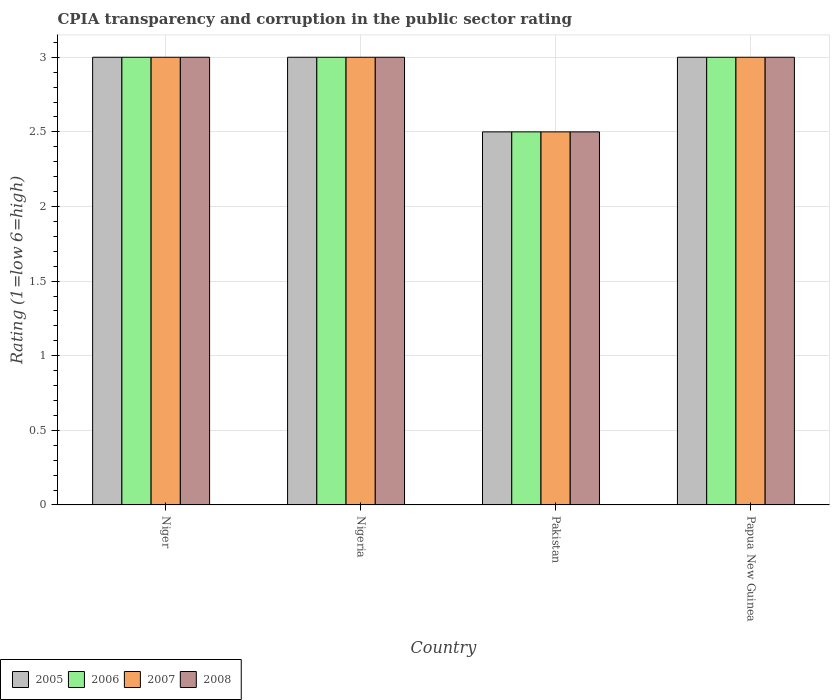How many groups of bars are there?
Offer a terse response. 4. Are the number of bars per tick equal to the number of legend labels?
Offer a terse response. Yes. Are the number of bars on each tick of the X-axis equal?
Keep it short and to the point. Yes. How many bars are there on the 2nd tick from the right?
Keep it short and to the point. 4. What is the label of the 3rd group of bars from the left?
Offer a terse response. Pakistan. Across all countries, what is the maximum CPIA rating in 2006?
Ensure brevity in your answer.  3. Across all countries, what is the minimum CPIA rating in 2005?
Provide a succinct answer. 2.5. In which country was the CPIA rating in 2008 maximum?
Keep it short and to the point. Niger. In which country was the CPIA rating in 2005 minimum?
Ensure brevity in your answer.  Pakistan. What is the difference between the CPIA rating in 2007 in Niger and the CPIA rating in 2006 in Papua New Guinea?
Your response must be concise. 0. What is the average CPIA rating in 2006 per country?
Make the answer very short. 2.88. In how many countries, is the CPIA rating in 2008 greater than 0.8?
Offer a very short reply. 4. Is the CPIA rating in 2005 in Nigeria less than that in Pakistan?
Ensure brevity in your answer.  No. Is the difference between the CPIA rating in 2007 in Niger and Papua New Guinea greater than the difference between the CPIA rating in 2008 in Niger and Papua New Guinea?
Offer a very short reply. No. In how many countries, is the CPIA rating in 2006 greater than the average CPIA rating in 2006 taken over all countries?
Keep it short and to the point. 3. What does the 4th bar from the left in Pakistan represents?
Your answer should be compact. 2008. What does the 4th bar from the right in Nigeria represents?
Give a very brief answer. 2005. Is it the case that in every country, the sum of the CPIA rating in 2008 and CPIA rating in 2006 is greater than the CPIA rating in 2005?
Keep it short and to the point. Yes. How many bars are there?
Keep it short and to the point. 16. Are all the bars in the graph horizontal?
Ensure brevity in your answer.  No. What is the difference between two consecutive major ticks on the Y-axis?
Ensure brevity in your answer.  0.5. Does the graph contain any zero values?
Your answer should be compact. No. How many legend labels are there?
Make the answer very short. 4. What is the title of the graph?
Your response must be concise. CPIA transparency and corruption in the public sector rating. What is the Rating (1=low 6=high) in 2006 in Niger?
Offer a terse response. 3. What is the Rating (1=low 6=high) in 2007 in Niger?
Your answer should be compact. 3. What is the Rating (1=low 6=high) of 2008 in Niger?
Ensure brevity in your answer.  3. What is the Rating (1=low 6=high) in 2006 in Nigeria?
Your answer should be very brief. 3. What is the Rating (1=low 6=high) of 2008 in Nigeria?
Ensure brevity in your answer.  3. What is the Rating (1=low 6=high) in 2005 in Pakistan?
Provide a short and direct response. 2.5. What is the Rating (1=low 6=high) of 2005 in Papua New Guinea?
Offer a very short reply. 3. What is the Rating (1=low 6=high) in 2006 in Papua New Guinea?
Offer a terse response. 3. Across all countries, what is the maximum Rating (1=low 6=high) of 2006?
Provide a short and direct response. 3. Across all countries, what is the minimum Rating (1=low 6=high) of 2008?
Provide a succinct answer. 2.5. What is the total Rating (1=low 6=high) of 2005 in the graph?
Offer a very short reply. 11.5. What is the total Rating (1=low 6=high) of 2006 in the graph?
Your answer should be very brief. 11.5. What is the total Rating (1=low 6=high) of 2008 in the graph?
Your response must be concise. 11.5. What is the difference between the Rating (1=low 6=high) of 2006 in Niger and that in Nigeria?
Provide a short and direct response. 0. What is the difference between the Rating (1=low 6=high) of 2005 in Niger and that in Pakistan?
Make the answer very short. 0.5. What is the difference between the Rating (1=low 6=high) of 2007 in Niger and that in Pakistan?
Provide a succinct answer. 0.5. What is the difference between the Rating (1=low 6=high) of 2006 in Niger and that in Papua New Guinea?
Your answer should be very brief. 0. What is the difference between the Rating (1=low 6=high) in 2007 in Niger and that in Papua New Guinea?
Offer a terse response. 0. What is the difference between the Rating (1=low 6=high) of 2008 in Niger and that in Papua New Guinea?
Offer a very short reply. 0. What is the difference between the Rating (1=low 6=high) in 2006 in Nigeria and that in Pakistan?
Your answer should be very brief. 0.5. What is the difference between the Rating (1=low 6=high) in 2007 in Nigeria and that in Pakistan?
Provide a short and direct response. 0.5. What is the difference between the Rating (1=low 6=high) of 2008 in Nigeria and that in Pakistan?
Give a very brief answer. 0.5. What is the difference between the Rating (1=low 6=high) of 2005 in Nigeria and that in Papua New Guinea?
Provide a short and direct response. 0. What is the difference between the Rating (1=low 6=high) of 2007 in Nigeria and that in Papua New Guinea?
Ensure brevity in your answer.  0. What is the difference between the Rating (1=low 6=high) in 2008 in Nigeria and that in Papua New Guinea?
Your answer should be very brief. 0. What is the difference between the Rating (1=low 6=high) of 2005 in Pakistan and that in Papua New Guinea?
Give a very brief answer. -0.5. What is the difference between the Rating (1=low 6=high) in 2005 in Niger and the Rating (1=low 6=high) in 2008 in Nigeria?
Keep it short and to the point. 0. What is the difference between the Rating (1=low 6=high) of 2006 in Niger and the Rating (1=low 6=high) of 2007 in Nigeria?
Provide a succinct answer. 0. What is the difference between the Rating (1=low 6=high) in 2006 in Niger and the Rating (1=low 6=high) in 2008 in Nigeria?
Provide a succinct answer. 0. What is the difference between the Rating (1=low 6=high) in 2007 in Niger and the Rating (1=low 6=high) in 2008 in Nigeria?
Give a very brief answer. 0. What is the difference between the Rating (1=low 6=high) of 2005 in Niger and the Rating (1=low 6=high) of 2006 in Pakistan?
Your answer should be very brief. 0.5. What is the difference between the Rating (1=low 6=high) of 2005 in Niger and the Rating (1=low 6=high) of 2007 in Pakistan?
Provide a short and direct response. 0.5. What is the difference between the Rating (1=low 6=high) in 2005 in Niger and the Rating (1=low 6=high) in 2008 in Pakistan?
Offer a terse response. 0.5. What is the difference between the Rating (1=low 6=high) in 2006 in Niger and the Rating (1=low 6=high) in 2007 in Pakistan?
Your answer should be very brief. 0.5. What is the difference between the Rating (1=low 6=high) of 2006 in Niger and the Rating (1=low 6=high) of 2008 in Pakistan?
Provide a succinct answer. 0.5. What is the difference between the Rating (1=low 6=high) of 2007 in Niger and the Rating (1=low 6=high) of 2008 in Pakistan?
Your response must be concise. 0.5. What is the difference between the Rating (1=low 6=high) in 2005 in Niger and the Rating (1=low 6=high) in 2007 in Papua New Guinea?
Ensure brevity in your answer.  0. What is the difference between the Rating (1=low 6=high) of 2006 in Niger and the Rating (1=low 6=high) of 2008 in Papua New Guinea?
Your response must be concise. 0. What is the difference between the Rating (1=low 6=high) of 2005 in Nigeria and the Rating (1=low 6=high) of 2006 in Pakistan?
Offer a very short reply. 0.5. What is the difference between the Rating (1=low 6=high) in 2005 in Nigeria and the Rating (1=low 6=high) in 2007 in Pakistan?
Ensure brevity in your answer.  0.5. What is the difference between the Rating (1=low 6=high) in 2005 in Nigeria and the Rating (1=low 6=high) in 2008 in Pakistan?
Keep it short and to the point. 0.5. What is the difference between the Rating (1=low 6=high) in 2006 in Nigeria and the Rating (1=low 6=high) in 2007 in Pakistan?
Your answer should be very brief. 0.5. What is the difference between the Rating (1=low 6=high) in 2006 in Nigeria and the Rating (1=low 6=high) in 2008 in Pakistan?
Provide a succinct answer. 0.5. What is the difference between the Rating (1=low 6=high) of 2005 in Nigeria and the Rating (1=low 6=high) of 2007 in Papua New Guinea?
Your answer should be very brief. 0. What is the difference between the Rating (1=low 6=high) in 2005 in Nigeria and the Rating (1=low 6=high) in 2008 in Papua New Guinea?
Your answer should be very brief. 0. What is the difference between the Rating (1=low 6=high) of 2006 in Nigeria and the Rating (1=low 6=high) of 2007 in Papua New Guinea?
Offer a very short reply. 0. What is the difference between the Rating (1=low 6=high) in 2006 in Nigeria and the Rating (1=low 6=high) in 2008 in Papua New Guinea?
Offer a terse response. 0. What is the difference between the Rating (1=low 6=high) in 2005 in Pakistan and the Rating (1=low 6=high) in 2006 in Papua New Guinea?
Make the answer very short. -0.5. What is the difference between the Rating (1=low 6=high) of 2005 in Pakistan and the Rating (1=low 6=high) of 2008 in Papua New Guinea?
Offer a terse response. -0.5. What is the difference between the Rating (1=low 6=high) of 2006 in Pakistan and the Rating (1=low 6=high) of 2007 in Papua New Guinea?
Give a very brief answer. -0.5. What is the difference between the Rating (1=low 6=high) of 2006 in Pakistan and the Rating (1=low 6=high) of 2008 in Papua New Guinea?
Offer a very short reply. -0.5. What is the difference between the Rating (1=low 6=high) of 2007 in Pakistan and the Rating (1=low 6=high) of 2008 in Papua New Guinea?
Give a very brief answer. -0.5. What is the average Rating (1=low 6=high) of 2005 per country?
Keep it short and to the point. 2.88. What is the average Rating (1=low 6=high) of 2006 per country?
Your answer should be very brief. 2.88. What is the average Rating (1=low 6=high) in 2007 per country?
Provide a succinct answer. 2.88. What is the average Rating (1=low 6=high) in 2008 per country?
Your response must be concise. 2.88. What is the difference between the Rating (1=low 6=high) of 2005 and Rating (1=low 6=high) of 2007 in Niger?
Your answer should be very brief. 0. What is the difference between the Rating (1=low 6=high) of 2006 and Rating (1=low 6=high) of 2008 in Niger?
Offer a very short reply. 0. What is the difference between the Rating (1=low 6=high) of 2006 and Rating (1=low 6=high) of 2007 in Nigeria?
Your response must be concise. 0. What is the difference between the Rating (1=low 6=high) of 2006 and Rating (1=low 6=high) of 2008 in Nigeria?
Make the answer very short. 0. What is the difference between the Rating (1=low 6=high) of 2005 and Rating (1=low 6=high) of 2006 in Pakistan?
Offer a terse response. 0. What is the difference between the Rating (1=low 6=high) of 2006 and Rating (1=low 6=high) of 2007 in Pakistan?
Offer a terse response. 0. What is the difference between the Rating (1=low 6=high) of 2006 and Rating (1=low 6=high) of 2008 in Papua New Guinea?
Give a very brief answer. 0. What is the difference between the Rating (1=low 6=high) in 2007 and Rating (1=low 6=high) in 2008 in Papua New Guinea?
Keep it short and to the point. 0. What is the ratio of the Rating (1=low 6=high) of 2008 in Niger to that in Nigeria?
Your answer should be compact. 1. What is the ratio of the Rating (1=low 6=high) of 2005 in Niger to that in Pakistan?
Make the answer very short. 1.2. What is the ratio of the Rating (1=low 6=high) in 2006 in Niger to that in Pakistan?
Give a very brief answer. 1.2. What is the ratio of the Rating (1=low 6=high) of 2008 in Niger to that in Pakistan?
Your answer should be very brief. 1.2. What is the ratio of the Rating (1=low 6=high) in 2005 in Niger to that in Papua New Guinea?
Offer a terse response. 1. What is the ratio of the Rating (1=low 6=high) of 2007 in Niger to that in Papua New Guinea?
Make the answer very short. 1. What is the ratio of the Rating (1=low 6=high) in 2008 in Niger to that in Papua New Guinea?
Your response must be concise. 1. What is the ratio of the Rating (1=low 6=high) in 2006 in Nigeria to that in Pakistan?
Keep it short and to the point. 1.2. What is the ratio of the Rating (1=low 6=high) in 2007 in Nigeria to that in Pakistan?
Provide a short and direct response. 1.2. What is the ratio of the Rating (1=low 6=high) of 2008 in Nigeria to that in Pakistan?
Give a very brief answer. 1.2. What is the ratio of the Rating (1=low 6=high) of 2006 in Nigeria to that in Papua New Guinea?
Your response must be concise. 1. What is the ratio of the Rating (1=low 6=high) of 2008 in Nigeria to that in Papua New Guinea?
Your answer should be compact. 1. What is the ratio of the Rating (1=low 6=high) of 2005 in Pakistan to that in Papua New Guinea?
Your answer should be compact. 0.83. What is the ratio of the Rating (1=low 6=high) of 2006 in Pakistan to that in Papua New Guinea?
Ensure brevity in your answer.  0.83. What is the difference between the highest and the second highest Rating (1=low 6=high) of 2006?
Your answer should be compact. 0. What is the difference between the highest and the lowest Rating (1=low 6=high) of 2006?
Offer a very short reply. 0.5. What is the difference between the highest and the lowest Rating (1=low 6=high) of 2007?
Offer a very short reply. 0.5. What is the difference between the highest and the lowest Rating (1=low 6=high) of 2008?
Make the answer very short. 0.5. 